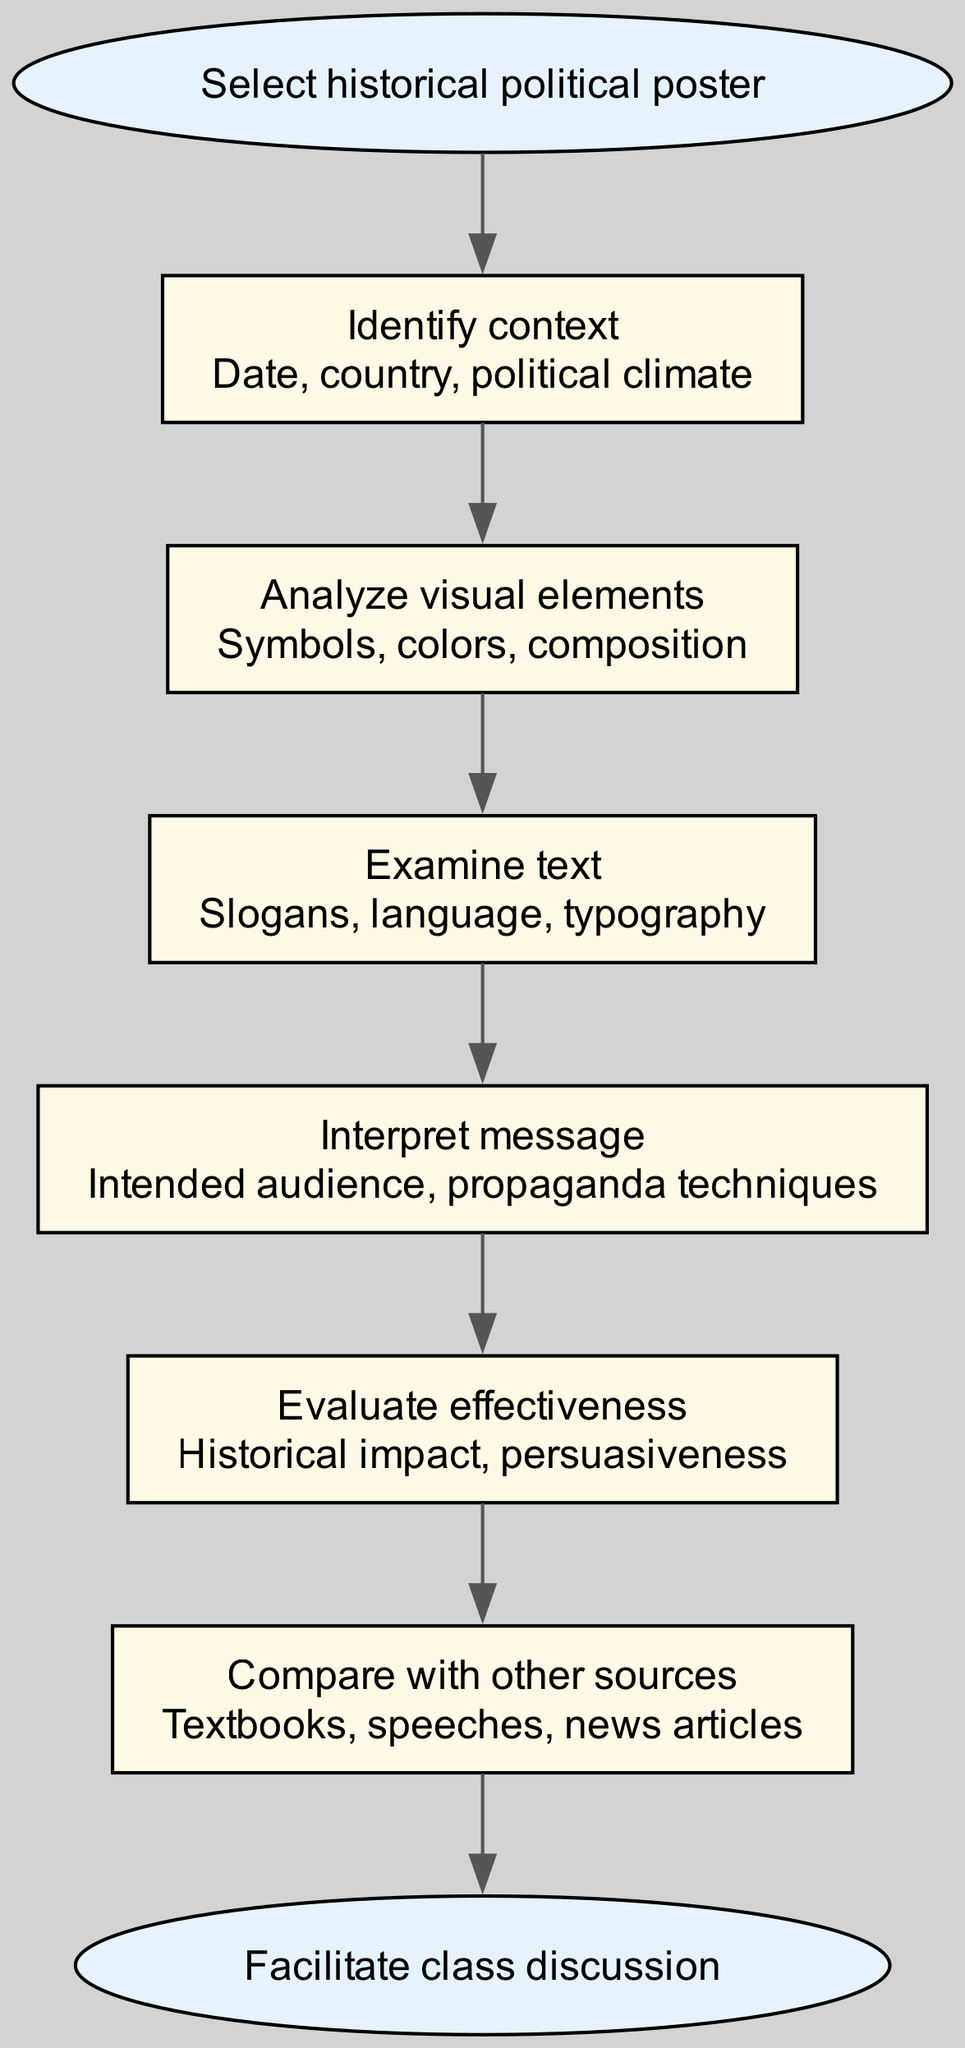What is the first step in analyzing a historical political poster? The first step, as indicated in the flow chart, is "Identify context." This is the step that follows the initial selection of a historical political poster, serving as the basis for further analysis.
Answer: Identify context How many steps are there in the analysis process? The flow chart outlines a total of six steps that are involved in analyzing historical political posters, leading from the starting point to the end discussion.
Answer: Six steps What does the last step of the diagram lead to? The last step in the flow chart concludes with "Facilitate class discussion," which is the final goal of the analysis process after evaluating the poster.
Answer: Facilitate class discussion What is analyzed in the second step? The second step focuses on "Analyze visual elements," detailing aspects such as symbols, colors, and composition of the poster to understand its impact.
Answer: Analyze visual elements What is the intended purpose of examining text in the analysis process? The purpose of examining text, as outlined in the flow chart's third step, is to understand elements such as slogans, language, and typography, which contribute to the overall message and effectiveness of the poster.
Answer: To understand slogans, language, and typography Which step involves determined audience and propaganda techniques? The step that involves interpreting the intended audience and propaganda techniques is "Interpret message," which is the fourth step in the analysis sequence. This is essential to grasp how the poster aims to influence its viewers.
Answer: Interpret message What comes after 'Analyze visual elements' in the flow of the diagram? Following 'Analyze visual elements', the next step in the flow chart is 'Examine text', maintaining the process of understanding the poster's deeper implications.
Answer: Examine text What is a critical element evaluated in the fifth step? A critical element evaluated in the fifth step is "Historical impact," which assesses how the poster influenced or affected the political landscape at the time it was created.
Answer: Historical impact 